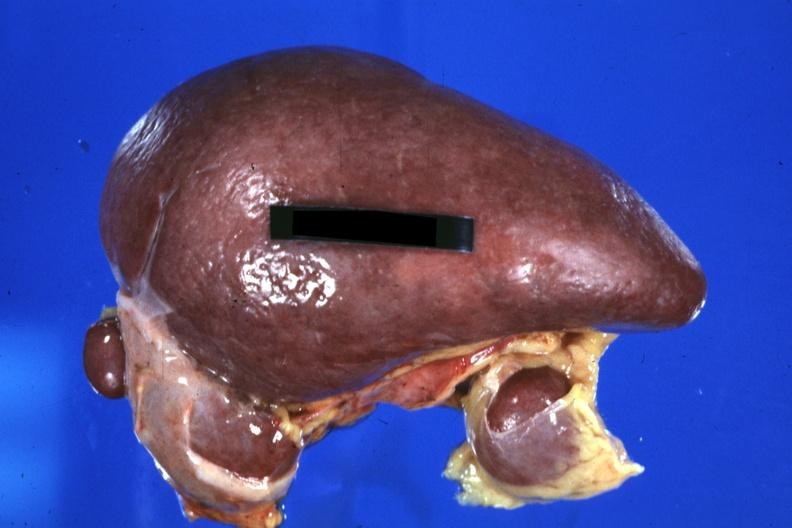how is spleen with three accessories 32yobf left isomerism and complex heart disease?
Answer the question using a single word or phrase. Congenital 